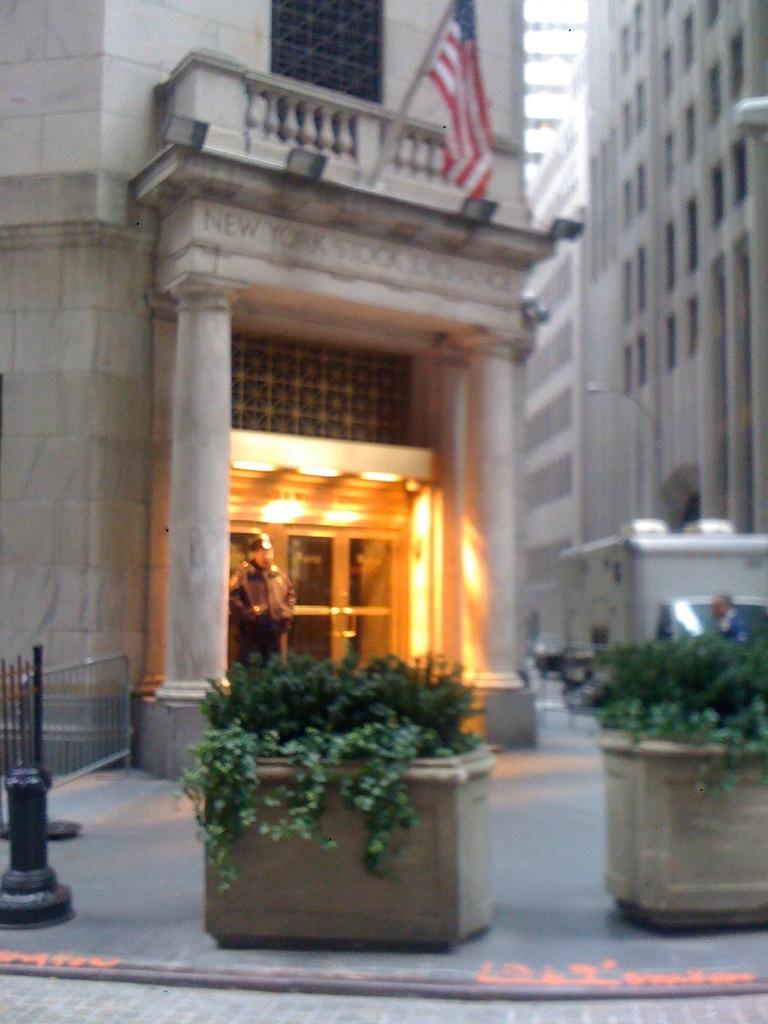In one or two sentences, can you explain what this image depicts? This image is taken outdoors. At the bottom of the image there is a floor. In the background there are a few buildings with walls, windows, doors, balconies and railings and there is a flag. A man is standing on the floor. There are a few plants in the pots. 